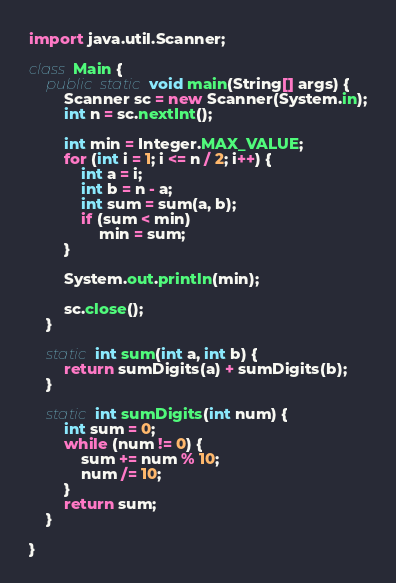Convert code to text. <code><loc_0><loc_0><loc_500><loc_500><_Java_>import java.util.Scanner;

class Main {
	public static void main(String[] args) {
		Scanner sc = new Scanner(System.in);
		int n = sc.nextInt();

		int min = Integer.MAX_VALUE;
		for (int i = 1; i <= n / 2; i++) {
			int a = i;
			int b = n - a;
			int sum = sum(a, b);
			if (sum < min)
				min = sum;
		}

		System.out.println(min);

		sc.close();
	}

	static int sum(int a, int b) {
		return sumDigits(a) + sumDigits(b);
	}

	static int sumDigits(int num) {
		int sum = 0;
		while (num != 0) {
			sum += num % 10;
			num /= 10;
		}
		return sum;
	}

}
</code> 